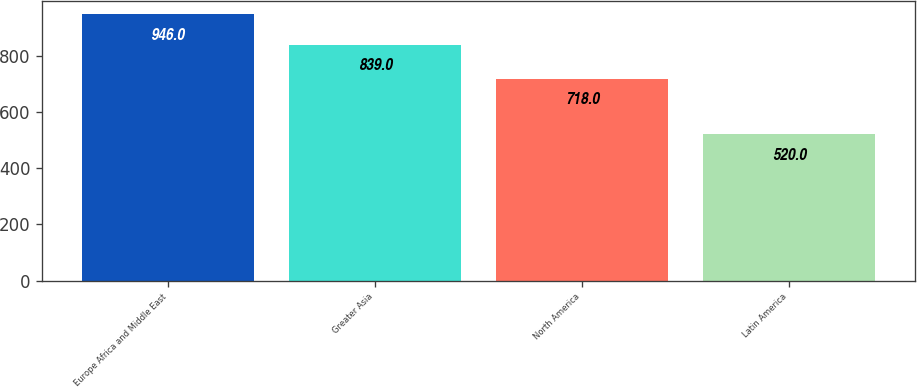Convert chart. <chart><loc_0><loc_0><loc_500><loc_500><bar_chart><fcel>Europe Africa and Middle East<fcel>Greater Asia<fcel>North America<fcel>Latin America<nl><fcel>946<fcel>839<fcel>718<fcel>520<nl></chart> 